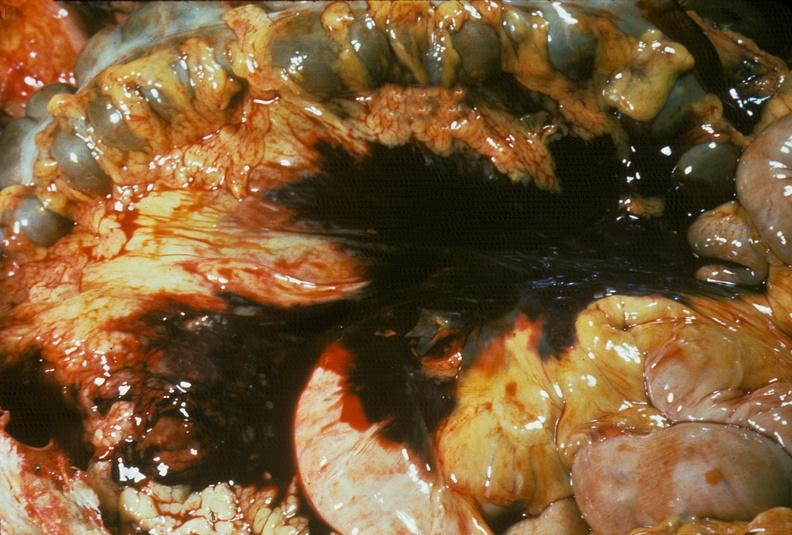what is present?
Answer the question using a single word or phrase. Abdomen 